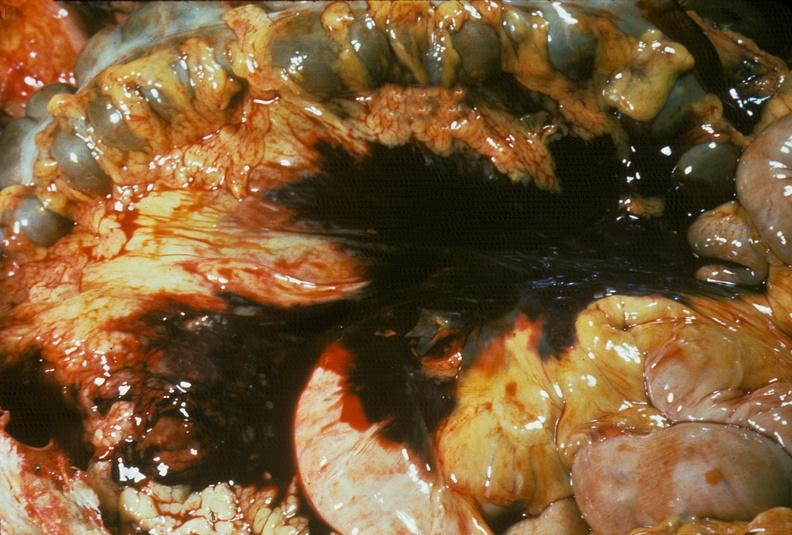what is present?
Answer the question using a single word or phrase. Abdomen 